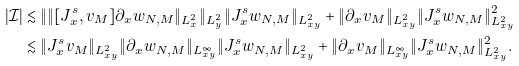<formula> <loc_0><loc_0><loc_500><loc_500>| \mathcal { I } | & \lesssim \| \| [ J ^ { s } _ { x } , v _ { M } ] \partial _ { x } w _ { N , M } \| _ { L ^ { 2 } _ { x } } \| _ { L ^ { 2 } _ { y } } \| J ^ { s } _ { x } w _ { N , M } \| _ { L ^ { 2 } _ { x y } } + \| \partial _ { x } v _ { M } \| _ { L ^ { 2 } _ { x y } } \| J ^ { s } _ { x } w _ { N , M } \| _ { L ^ { 2 } _ { x y } } ^ { 2 } \\ & \lesssim \| J ^ { s } _ { x } v _ { M } \| _ { L ^ { 2 } _ { x y } } \| \partial _ { x } w _ { N , M } \| _ { L ^ { \infty } _ { x y } } \| J ^ { s } _ { x } w _ { N , M } \| _ { L ^ { 2 } _ { x y } } + \| \partial _ { x } v _ { M } \| _ { L ^ { \infty } _ { x y } } \| J ^ { s } _ { x } w _ { N , M } \| _ { L ^ { 2 } _ { x y } } ^ { 2 } .</formula> 